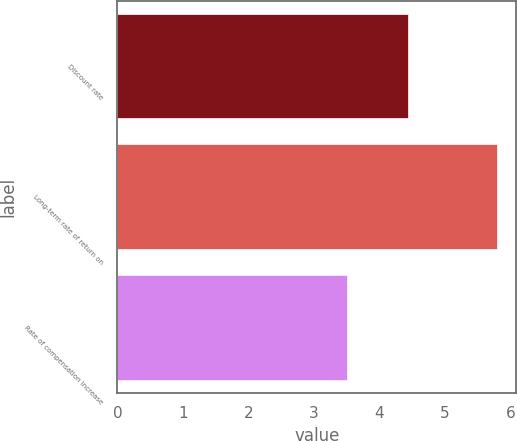Convert chart. <chart><loc_0><loc_0><loc_500><loc_500><bar_chart><fcel>Discount rate<fcel>Long-term rate of return on<fcel>Rate of compensation increase<nl><fcel>4.43<fcel>5.8<fcel>3.51<nl></chart> 